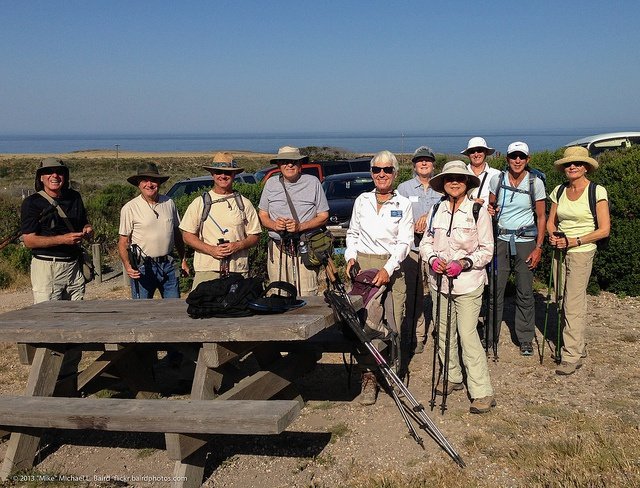Describe the objects in this image and their specific colors. I can see bench in gray and black tones, dining table in gray and black tones, people in gray, ivory, black, and tan tones, people in gray, white, black, and tan tones, and people in gray, black, and lightblue tones in this image. 